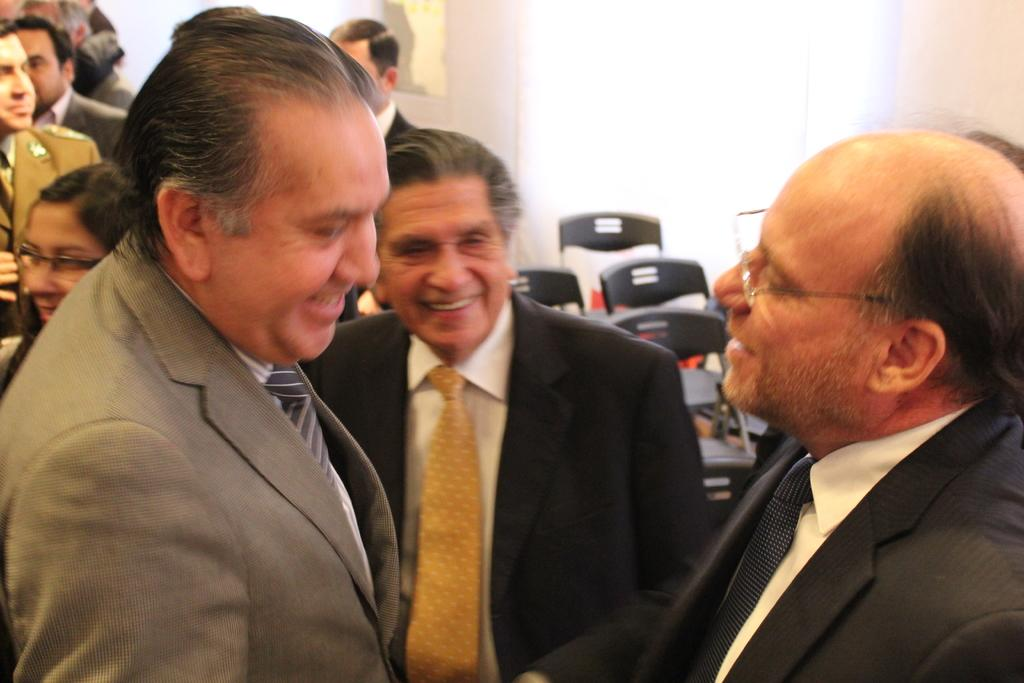What are the people in the image doing? The people in the image are standing. What type of clothing are the people wearing on their upper bodies? The people are wearing coats, shirts, and ties. What can be seen in the background of the image? There are chairs, a wall, and other objects visible in the background. Can you touch the net in the image? There is no net present in the image. 